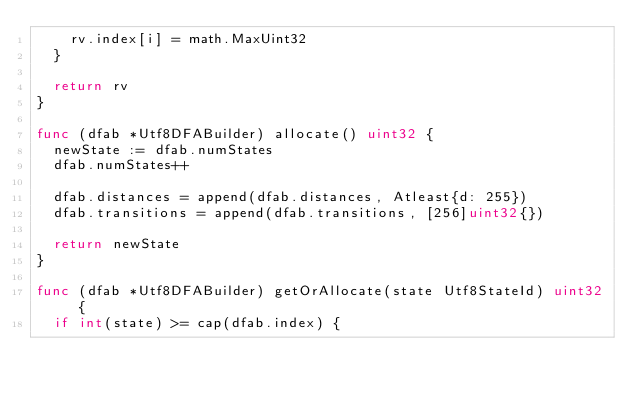<code> <loc_0><loc_0><loc_500><loc_500><_Go_>		rv.index[i] = math.MaxUint32
	}

	return rv
}

func (dfab *Utf8DFABuilder) allocate() uint32 {
	newState := dfab.numStates
	dfab.numStates++

	dfab.distances = append(dfab.distances, Atleast{d: 255})
	dfab.transitions = append(dfab.transitions, [256]uint32{})

	return newState
}

func (dfab *Utf8DFABuilder) getOrAllocate(state Utf8StateId) uint32 {
	if int(state) >= cap(dfab.index) {</code> 